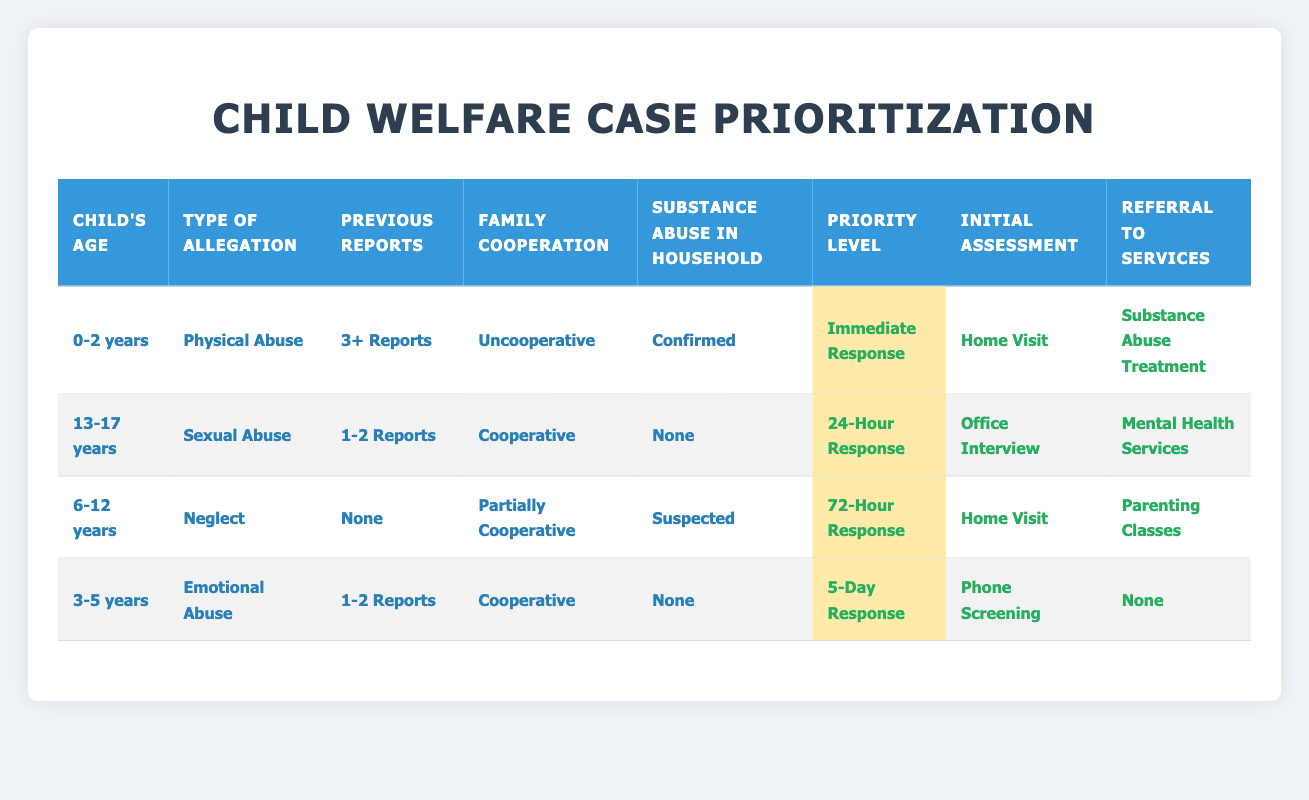What is the priority level for cases involving children aged 0 to 2 years with confirmed physical abuse and 3 or more previous reports? The table indicates that for this specific scenario (Child's Age: 0-2 years, Type of Allegation: Physical Abuse, Previous Reports: 3+ Reports, Family Cooperation: Uncooperative, Substance Abuse in Household: Confirmed), the priority level is "Immediate Response."
Answer: Immediate Response How many different types of allegations are considered in this table? By looking at the conditions listed under "Type of Allegation," we see the following four types: Physical Abuse, Sexual Abuse, Neglect, and Emotional Abuse. Thus, there are 4 types.
Answer: 4 Is there a case with a 72-hour response that has no previous reports? In the table, there is one case where the response is 72-Hour, which corresponds to the child's age of 6-12 years, type of allegation being Neglect, family cooperation being Partially Cooperative, and substance abuse being Suspected. The previous reports are listed as "None" in this case. Hence, this statement is true.
Answer: Yes What actions are taken for a 13 to 17 years old child who experienced sexual abuse and has 1 to 2 previous reports with family cooperation? According to the table, for this age group and type of allegation, the actions taken are: Priority Level is "24-Hour Response", Initial Assessment is "Office Interview", and Referral to Services is "Mental Health Services." Therefore, those are the actions taken for this case.
Answer: 24-Hour Response, Office Interview, Mental Health Services How many cases involve children where family cooperation is "Cooperative"? Reviewing the table, we can identify two cases where family cooperation is marked as "Cooperative." Specifically, they are cases with ages 13-17 (Sexual Abuse) and 3-5 (Emotional Abuse). Therefore, there are 2 cases with this cooperation level.
Answer: 2 What is the initial assessment for the case involving 6 to 12 years old children with neglect and suspected substance abuse? For this case, as per the table, the Initial Assessment required is a "Home Visit," corresponding to the priority level of "72-Hour Response" due to neglect and suspected substance abuse.
Answer: Home Visit In total, how many types of referrals are available in the table? The types of referrals listed under the Referral to Services column are: None, Parenting Classes, Substance Abuse Treatment, Mental Health Services, and Domestic Violence Support. Counting these gives us a total of 5 different referral types available.
Answer: 5 Does any case in the table involve confirmed substance abuse? Yes, there is a case listed in the table that includes confirmed substance abuse. This can be found in the first row under conditions for children aged 0-2 years, where confirmed substance abuse is part of the criteria.
Answer: Yes What is the response time for children aged 3 to 5 years old who are experiencing emotional abuse and have 1 to 2 previous reports with cooperative family cooperation? For this specific case, according to the table, the priority level is a "5-Day Response," indicating the response time required.
Answer: 5-Day Response 